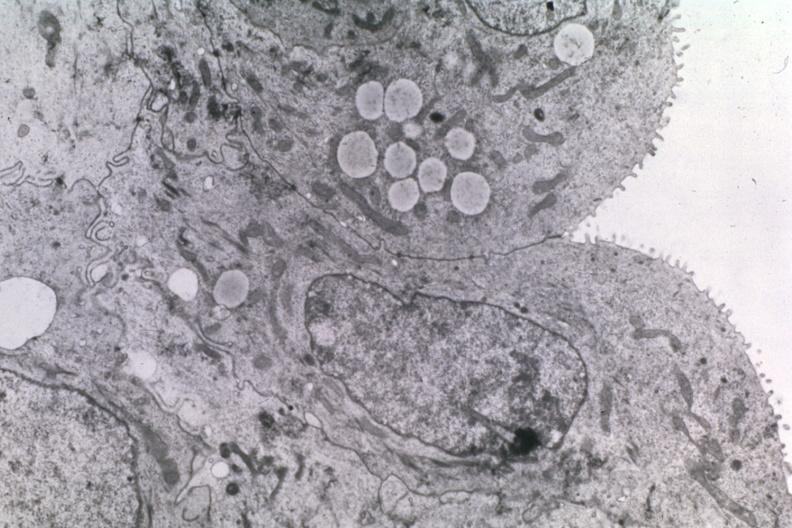s bone, skull present?
Answer the question using a single word or phrase. No 